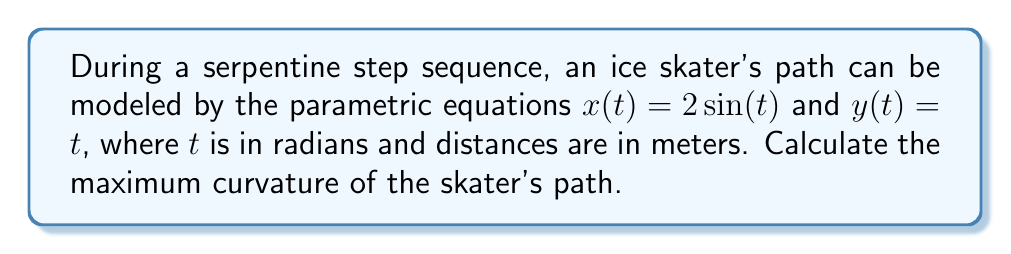What is the answer to this math problem? To find the maximum curvature of the skater's path, we'll follow these steps:

1) The formula for curvature $\kappa$ of a parametric curve is:

   $$\kappa = \frac{|x'y'' - y'x''|}{(x'^2 + y'^2)^{3/2}}$$

2) Calculate the first derivatives:
   $x'(t) = 2\cos(t)$
   $y'(t) = 1$

3) Calculate the second derivatives:
   $x''(t) = -2\sin(t)$
   $y''(t) = 0$

4) Substitute these into the curvature formula:

   $$\kappa = \frac{|2\cos(t) \cdot 0 - 1 \cdot (-2\sin(t))|}{(4\cos^2(t) + 1)^{3/2}}$$

5) Simplify:

   $$\kappa = \frac{2|\sin(t)|}{(4\cos^2(t) + 1)^{3/2}}$$

6) To find the maximum curvature, we need to maximize this expression. The numerator is maximum when $|\sin(t)| = 1$, which occurs when $t = \frac{\pi}{2}$ or $\frac{3\pi}{2}$. At these points, $\cos(t) = 0$.

7) Substituting these values:

   $$\kappa_{max} = \frac{2 \cdot 1}{(4 \cdot 0^2 + 1)^{3/2}} = \frac{2}{1^{3/2}} = 2$$

Therefore, the maximum curvature of the skater's path is 2 m^(-1).
Answer: 2 m^(-1) 